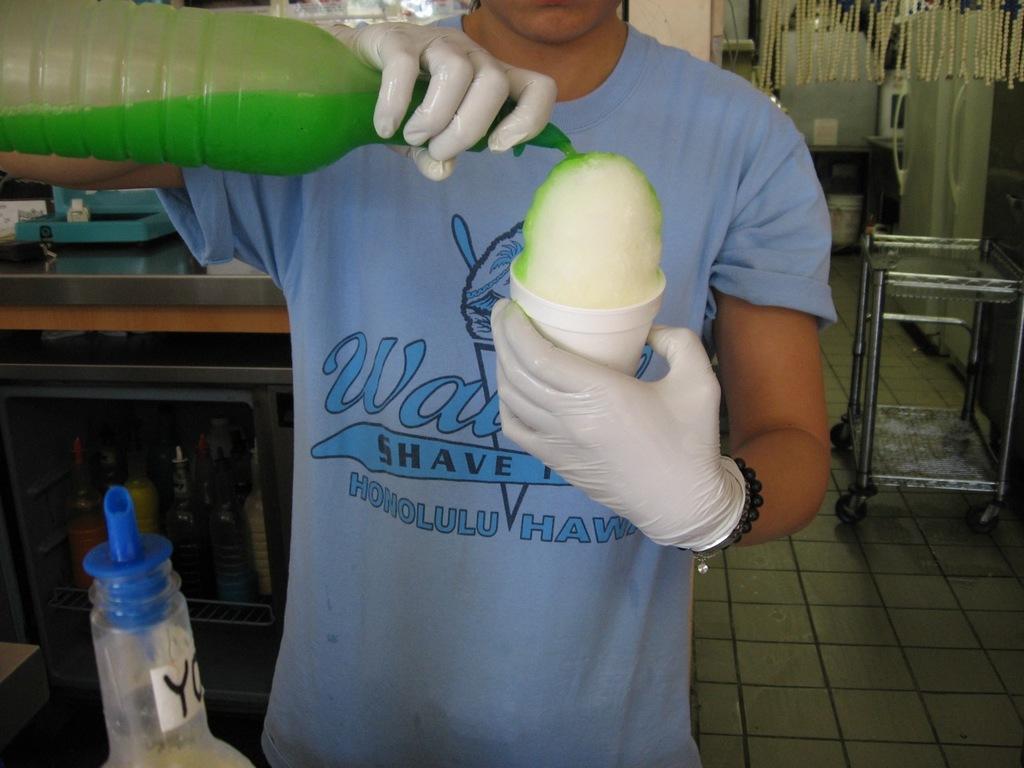Please provide a concise description of this image. The person wearing blue shirt is mixing a color to an object which is in his hands. 